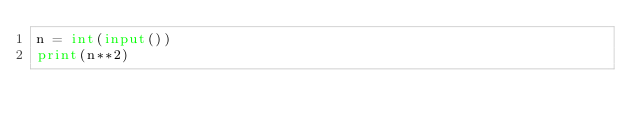<code> <loc_0><loc_0><loc_500><loc_500><_Python_>n = int(input())
print(n**2)</code> 